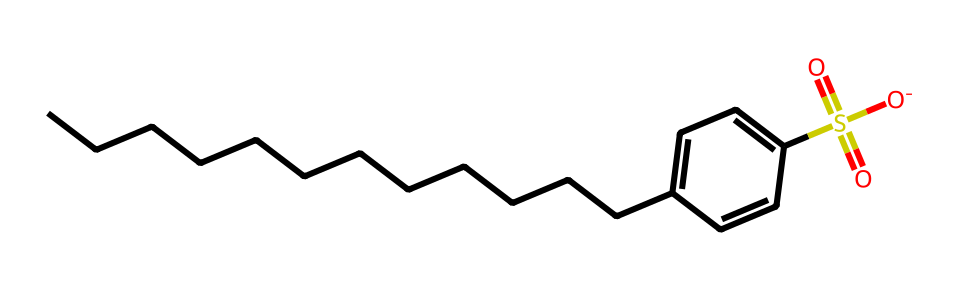What is the total number of carbon atoms in this chemical? By examining the SMILES representation, we can count the number of "C" characters present. There are 14 carbon atoms represented in the linear chain and the benzene ring portion.
Answer: 14 How many sulfur atoms are present in this chemical? In the SMILES representation, we see one "S" character that indicates the presence of a sulfur atom.
Answer: 1 What type of bond connects the sulfur to the oxygen in the sulfonate group? The "S(=O)(=O)" notation indicates that the sulfur atom is connected to two oxygen atoms via double bonds, which are typically stronger and more stable.
Answer: double bonds Which functional group is indicated by "S(=O)(=O)[O-]"? The notation indicates a sulfonate group, characterized by one sulfur atom bonded to three oxygen atoms, where one of the oxygen atoms carries a negative charge.
Answer: sulfonate How does the length of the carbon chain influence the detergent's biodegradability? A longer carbon chain in surfactants often leads to higher surface activity, but shorter chains are generally more biodegradable. This is because long alkyl chains can resist microbial breakdown, while shorter chains are easier for microbes to metabolize.
Answer: longer chains resist What property does the benzene ring impart to this detergent? The benzene ring introduces hydrophobic characteristics while simultaneously providing stability to the molecule, which aids in its effectiveness as a detergent.
Answer: hydrophobicity Is linear alkylbenzene sulfonate considered biodegradable? Linear alkylbenzene sulfonate is designed to be biodegradable, which means it is formulated to break down more easily in the environment compared to non-biodegradable detergents.
Answer: yes 